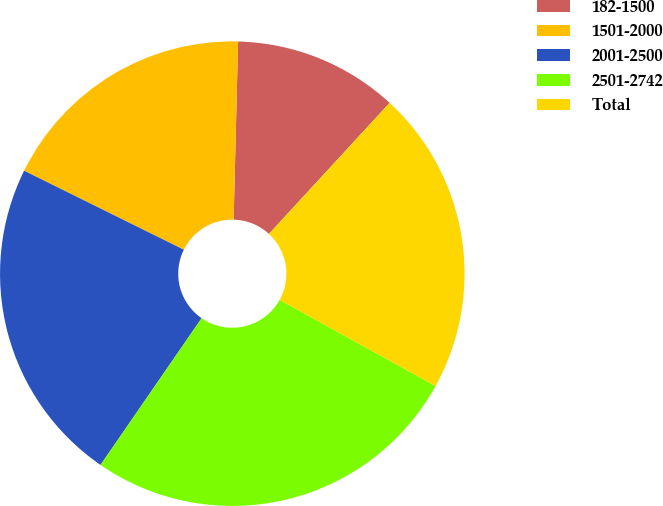Convert chart to OTSL. <chart><loc_0><loc_0><loc_500><loc_500><pie_chart><fcel>182-1500<fcel>1501-2000<fcel>2001-2500<fcel>2501-2742<fcel>Total<nl><fcel>11.45%<fcel>18.09%<fcel>22.71%<fcel>26.57%<fcel>21.19%<nl></chart> 